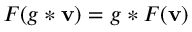<formula> <loc_0><loc_0><loc_500><loc_500>F ( g * v ) = g * F ( v )</formula> 